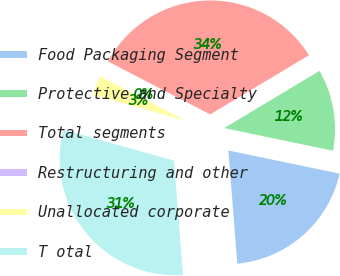Convert chart. <chart><loc_0><loc_0><loc_500><loc_500><pie_chart><fcel>Food Packaging Segment<fcel>Protective and Specialty<fcel>Total segments<fcel>Restructuring and other<fcel>Unallocated corporate<fcel>T otal<nl><fcel>20.49%<fcel>11.87%<fcel>33.79%<fcel>0.03%<fcel>3.26%<fcel>30.56%<nl></chart> 